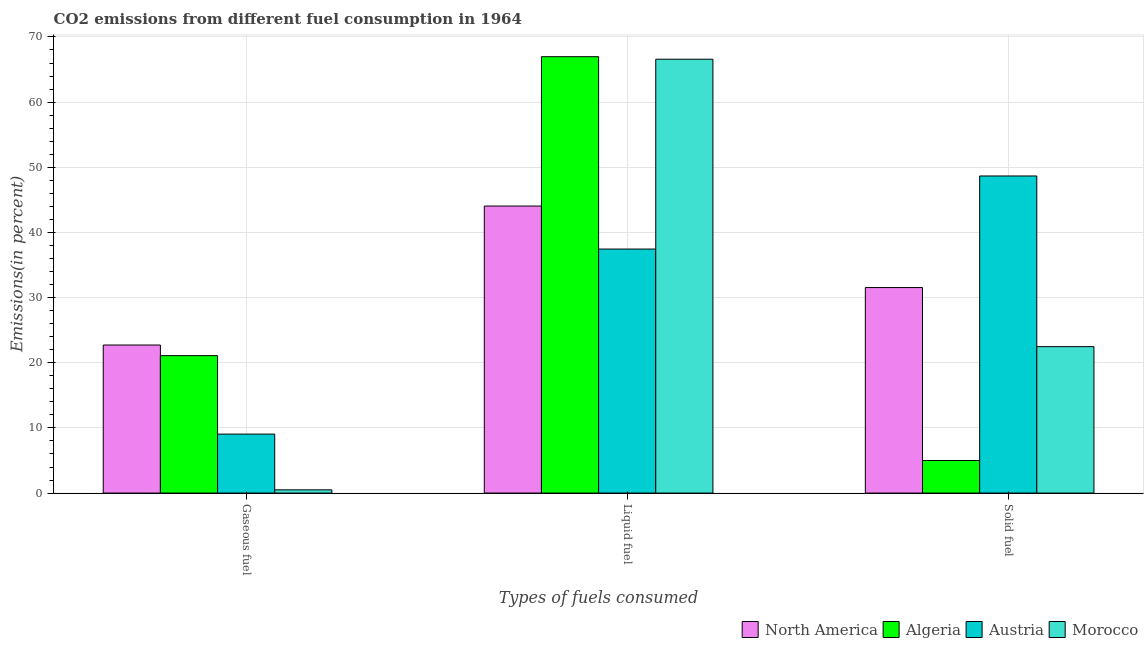Are the number of bars per tick equal to the number of legend labels?
Offer a very short reply. Yes. How many bars are there on the 1st tick from the left?
Your answer should be very brief. 4. What is the label of the 2nd group of bars from the left?
Ensure brevity in your answer.  Liquid fuel. What is the percentage of solid fuel emission in Austria?
Give a very brief answer. 48.66. Across all countries, what is the maximum percentage of gaseous fuel emission?
Offer a very short reply. 22.72. Across all countries, what is the minimum percentage of solid fuel emission?
Your response must be concise. 5. In which country was the percentage of gaseous fuel emission maximum?
Provide a short and direct response. North America. What is the total percentage of gaseous fuel emission in the graph?
Provide a succinct answer. 53.36. What is the difference between the percentage of gaseous fuel emission in Austria and that in Morocco?
Provide a short and direct response. 8.55. What is the difference between the percentage of gaseous fuel emission in Austria and the percentage of solid fuel emission in Algeria?
Keep it short and to the point. 4.05. What is the average percentage of gaseous fuel emission per country?
Your answer should be compact. 13.34. What is the difference between the percentage of gaseous fuel emission and percentage of solid fuel emission in Algeria?
Your answer should be very brief. 16.09. What is the ratio of the percentage of solid fuel emission in Austria to that in Morocco?
Make the answer very short. 2.17. What is the difference between the highest and the second highest percentage of solid fuel emission?
Give a very brief answer. 17.12. What is the difference between the highest and the lowest percentage of solid fuel emission?
Your answer should be compact. 43.67. What does the 4th bar from the left in Liquid fuel represents?
Provide a short and direct response. Morocco. What does the 3rd bar from the right in Gaseous fuel represents?
Your answer should be very brief. Algeria. How many bars are there?
Your answer should be compact. 12. Are all the bars in the graph horizontal?
Provide a succinct answer. No. How many countries are there in the graph?
Offer a terse response. 4. Does the graph contain any zero values?
Offer a terse response. No. Does the graph contain grids?
Provide a short and direct response. Yes. What is the title of the graph?
Provide a short and direct response. CO2 emissions from different fuel consumption in 1964. What is the label or title of the X-axis?
Give a very brief answer. Types of fuels consumed. What is the label or title of the Y-axis?
Make the answer very short. Emissions(in percent). What is the Emissions(in percent) of North America in Gaseous fuel?
Your answer should be compact. 22.72. What is the Emissions(in percent) in Algeria in Gaseous fuel?
Your response must be concise. 21.09. What is the Emissions(in percent) of Austria in Gaseous fuel?
Your answer should be compact. 9.05. What is the Emissions(in percent) of Morocco in Gaseous fuel?
Provide a succinct answer. 0.5. What is the Emissions(in percent) in North America in Liquid fuel?
Ensure brevity in your answer.  44.05. What is the Emissions(in percent) of Algeria in Liquid fuel?
Your answer should be very brief. 66.97. What is the Emissions(in percent) in Austria in Liquid fuel?
Offer a very short reply. 37.45. What is the Emissions(in percent) of Morocco in Liquid fuel?
Make the answer very short. 66.58. What is the Emissions(in percent) in North America in Solid fuel?
Offer a terse response. 31.54. What is the Emissions(in percent) in Algeria in Solid fuel?
Offer a very short reply. 5. What is the Emissions(in percent) in Austria in Solid fuel?
Ensure brevity in your answer.  48.66. What is the Emissions(in percent) in Morocco in Solid fuel?
Provide a short and direct response. 22.47. Across all Types of fuels consumed, what is the maximum Emissions(in percent) of North America?
Ensure brevity in your answer.  44.05. Across all Types of fuels consumed, what is the maximum Emissions(in percent) of Algeria?
Your response must be concise. 66.97. Across all Types of fuels consumed, what is the maximum Emissions(in percent) in Austria?
Offer a very short reply. 48.66. Across all Types of fuels consumed, what is the maximum Emissions(in percent) of Morocco?
Offer a very short reply. 66.58. Across all Types of fuels consumed, what is the minimum Emissions(in percent) in North America?
Offer a very short reply. 22.72. Across all Types of fuels consumed, what is the minimum Emissions(in percent) in Algeria?
Your answer should be very brief. 5. Across all Types of fuels consumed, what is the minimum Emissions(in percent) of Austria?
Offer a terse response. 9.05. Across all Types of fuels consumed, what is the minimum Emissions(in percent) of Morocco?
Provide a succinct answer. 0.5. What is the total Emissions(in percent) in North America in the graph?
Offer a very short reply. 98.31. What is the total Emissions(in percent) in Algeria in the graph?
Make the answer very short. 93.06. What is the total Emissions(in percent) in Austria in the graph?
Your answer should be very brief. 95.16. What is the total Emissions(in percent) of Morocco in the graph?
Keep it short and to the point. 89.55. What is the difference between the Emissions(in percent) of North America in Gaseous fuel and that in Liquid fuel?
Provide a succinct answer. -21.33. What is the difference between the Emissions(in percent) in Algeria in Gaseous fuel and that in Liquid fuel?
Your answer should be very brief. -45.88. What is the difference between the Emissions(in percent) in Austria in Gaseous fuel and that in Liquid fuel?
Your answer should be compact. -28.4. What is the difference between the Emissions(in percent) of Morocco in Gaseous fuel and that in Liquid fuel?
Offer a terse response. -66.09. What is the difference between the Emissions(in percent) of North America in Gaseous fuel and that in Solid fuel?
Your response must be concise. -8.82. What is the difference between the Emissions(in percent) in Algeria in Gaseous fuel and that in Solid fuel?
Ensure brevity in your answer.  16.09. What is the difference between the Emissions(in percent) of Austria in Gaseous fuel and that in Solid fuel?
Give a very brief answer. -39.61. What is the difference between the Emissions(in percent) in Morocco in Gaseous fuel and that in Solid fuel?
Offer a terse response. -21.97. What is the difference between the Emissions(in percent) in North America in Liquid fuel and that in Solid fuel?
Provide a succinct answer. 12.51. What is the difference between the Emissions(in percent) in Algeria in Liquid fuel and that in Solid fuel?
Offer a terse response. 61.97. What is the difference between the Emissions(in percent) of Austria in Liquid fuel and that in Solid fuel?
Offer a terse response. -11.21. What is the difference between the Emissions(in percent) of Morocco in Liquid fuel and that in Solid fuel?
Your response must be concise. 44.11. What is the difference between the Emissions(in percent) in North America in Gaseous fuel and the Emissions(in percent) in Algeria in Liquid fuel?
Provide a short and direct response. -44.25. What is the difference between the Emissions(in percent) in North America in Gaseous fuel and the Emissions(in percent) in Austria in Liquid fuel?
Give a very brief answer. -14.73. What is the difference between the Emissions(in percent) of North America in Gaseous fuel and the Emissions(in percent) of Morocco in Liquid fuel?
Your answer should be very brief. -43.86. What is the difference between the Emissions(in percent) in Algeria in Gaseous fuel and the Emissions(in percent) in Austria in Liquid fuel?
Give a very brief answer. -16.36. What is the difference between the Emissions(in percent) in Algeria in Gaseous fuel and the Emissions(in percent) in Morocco in Liquid fuel?
Provide a short and direct response. -45.49. What is the difference between the Emissions(in percent) in Austria in Gaseous fuel and the Emissions(in percent) in Morocco in Liquid fuel?
Keep it short and to the point. -57.53. What is the difference between the Emissions(in percent) in North America in Gaseous fuel and the Emissions(in percent) in Algeria in Solid fuel?
Your answer should be compact. 17.72. What is the difference between the Emissions(in percent) in North America in Gaseous fuel and the Emissions(in percent) in Austria in Solid fuel?
Your answer should be very brief. -25.94. What is the difference between the Emissions(in percent) in North America in Gaseous fuel and the Emissions(in percent) in Morocco in Solid fuel?
Give a very brief answer. 0.25. What is the difference between the Emissions(in percent) of Algeria in Gaseous fuel and the Emissions(in percent) of Austria in Solid fuel?
Offer a terse response. -27.57. What is the difference between the Emissions(in percent) of Algeria in Gaseous fuel and the Emissions(in percent) of Morocco in Solid fuel?
Offer a terse response. -1.38. What is the difference between the Emissions(in percent) in Austria in Gaseous fuel and the Emissions(in percent) in Morocco in Solid fuel?
Offer a very short reply. -13.42. What is the difference between the Emissions(in percent) in North America in Liquid fuel and the Emissions(in percent) in Algeria in Solid fuel?
Ensure brevity in your answer.  39.05. What is the difference between the Emissions(in percent) in North America in Liquid fuel and the Emissions(in percent) in Austria in Solid fuel?
Provide a short and direct response. -4.61. What is the difference between the Emissions(in percent) of North America in Liquid fuel and the Emissions(in percent) of Morocco in Solid fuel?
Your answer should be very brief. 21.58. What is the difference between the Emissions(in percent) of Algeria in Liquid fuel and the Emissions(in percent) of Austria in Solid fuel?
Your response must be concise. 18.31. What is the difference between the Emissions(in percent) of Algeria in Liquid fuel and the Emissions(in percent) of Morocco in Solid fuel?
Your answer should be compact. 44.5. What is the difference between the Emissions(in percent) in Austria in Liquid fuel and the Emissions(in percent) in Morocco in Solid fuel?
Your response must be concise. 14.98. What is the average Emissions(in percent) in North America per Types of fuels consumed?
Offer a very short reply. 32.77. What is the average Emissions(in percent) of Algeria per Types of fuels consumed?
Give a very brief answer. 31.02. What is the average Emissions(in percent) in Austria per Types of fuels consumed?
Ensure brevity in your answer.  31.72. What is the average Emissions(in percent) in Morocco per Types of fuels consumed?
Your response must be concise. 29.85. What is the difference between the Emissions(in percent) in North America and Emissions(in percent) in Algeria in Gaseous fuel?
Your answer should be compact. 1.63. What is the difference between the Emissions(in percent) of North America and Emissions(in percent) of Austria in Gaseous fuel?
Provide a succinct answer. 13.67. What is the difference between the Emissions(in percent) of North America and Emissions(in percent) of Morocco in Gaseous fuel?
Your answer should be very brief. 22.22. What is the difference between the Emissions(in percent) of Algeria and Emissions(in percent) of Austria in Gaseous fuel?
Provide a short and direct response. 12.04. What is the difference between the Emissions(in percent) of Algeria and Emissions(in percent) of Morocco in Gaseous fuel?
Make the answer very short. 20.59. What is the difference between the Emissions(in percent) in Austria and Emissions(in percent) in Morocco in Gaseous fuel?
Offer a very short reply. 8.55. What is the difference between the Emissions(in percent) of North America and Emissions(in percent) of Algeria in Liquid fuel?
Provide a succinct answer. -22.92. What is the difference between the Emissions(in percent) of North America and Emissions(in percent) of Austria in Liquid fuel?
Make the answer very short. 6.6. What is the difference between the Emissions(in percent) in North America and Emissions(in percent) in Morocco in Liquid fuel?
Provide a succinct answer. -22.53. What is the difference between the Emissions(in percent) of Algeria and Emissions(in percent) of Austria in Liquid fuel?
Provide a short and direct response. 29.52. What is the difference between the Emissions(in percent) of Algeria and Emissions(in percent) of Morocco in Liquid fuel?
Provide a short and direct response. 0.39. What is the difference between the Emissions(in percent) of Austria and Emissions(in percent) of Morocco in Liquid fuel?
Provide a succinct answer. -29.14. What is the difference between the Emissions(in percent) of North America and Emissions(in percent) of Algeria in Solid fuel?
Ensure brevity in your answer.  26.54. What is the difference between the Emissions(in percent) of North America and Emissions(in percent) of Austria in Solid fuel?
Offer a very short reply. -17.12. What is the difference between the Emissions(in percent) in North America and Emissions(in percent) in Morocco in Solid fuel?
Offer a very short reply. 9.07. What is the difference between the Emissions(in percent) in Algeria and Emissions(in percent) in Austria in Solid fuel?
Offer a terse response. -43.67. What is the difference between the Emissions(in percent) of Algeria and Emissions(in percent) of Morocco in Solid fuel?
Your response must be concise. -17.47. What is the difference between the Emissions(in percent) of Austria and Emissions(in percent) of Morocco in Solid fuel?
Make the answer very short. 26.19. What is the ratio of the Emissions(in percent) in North America in Gaseous fuel to that in Liquid fuel?
Your response must be concise. 0.52. What is the ratio of the Emissions(in percent) in Algeria in Gaseous fuel to that in Liquid fuel?
Provide a short and direct response. 0.31. What is the ratio of the Emissions(in percent) in Austria in Gaseous fuel to that in Liquid fuel?
Your answer should be compact. 0.24. What is the ratio of the Emissions(in percent) in Morocco in Gaseous fuel to that in Liquid fuel?
Make the answer very short. 0.01. What is the ratio of the Emissions(in percent) in North America in Gaseous fuel to that in Solid fuel?
Give a very brief answer. 0.72. What is the ratio of the Emissions(in percent) in Algeria in Gaseous fuel to that in Solid fuel?
Your answer should be compact. 4.22. What is the ratio of the Emissions(in percent) in Austria in Gaseous fuel to that in Solid fuel?
Keep it short and to the point. 0.19. What is the ratio of the Emissions(in percent) in Morocco in Gaseous fuel to that in Solid fuel?
Offer a terse response. 0.02. What is the ratio of the Emissions(in percent) in North America in Liquid fuel to that in Solid fuel?
Offer a terse response. 1.4. What is the ratio of the Emissions(in percent) in Algeria in Liquid fuel to that in Solid fuel?
Give a very brief answer. 13.4. What is the ratio of the Emissions(in percent) of Austria in Liquid fuel to that in Solid fuel?
Give a very brief answer. 0.77. What is the ratio of the Emissions(in percent) of Morocco in Liquid fuel to that in Solid fuel?
Offer a terse response. 2.96. What is the difference between the highest and the second highest Emissions(in percent) of North America?
Your answer should be compact. 12.51. What is the difference between the highest and the second highest Emissions(in percent) of Algeria?
Ensure brevity in your answer.  45.88. What is the difference between the highest and the second highest Emissions(in percent) in Austria?
Provide a succinct answer. 11.21. What is the difference between the highest and the second highest Emissions(in percent) in Morocco?
Ensure brevity in your answer.  44.11. What is the difference between the highest and the lowest Emissions(in percent) of North America?
Your answer should be compact. 21.33. What is the difference between the highest and the lowest Emissions(in percent) in Algeria?
Your answer should be very brief. 61.97. What is the difference between the highest and the lowest Emissions(in percent) in Austria?
Provide a succinct answer. 39.61. What is the difference between the highest and the lowest Emissions(in percent) of Morocco?
Offer a terse response. 66.09. 